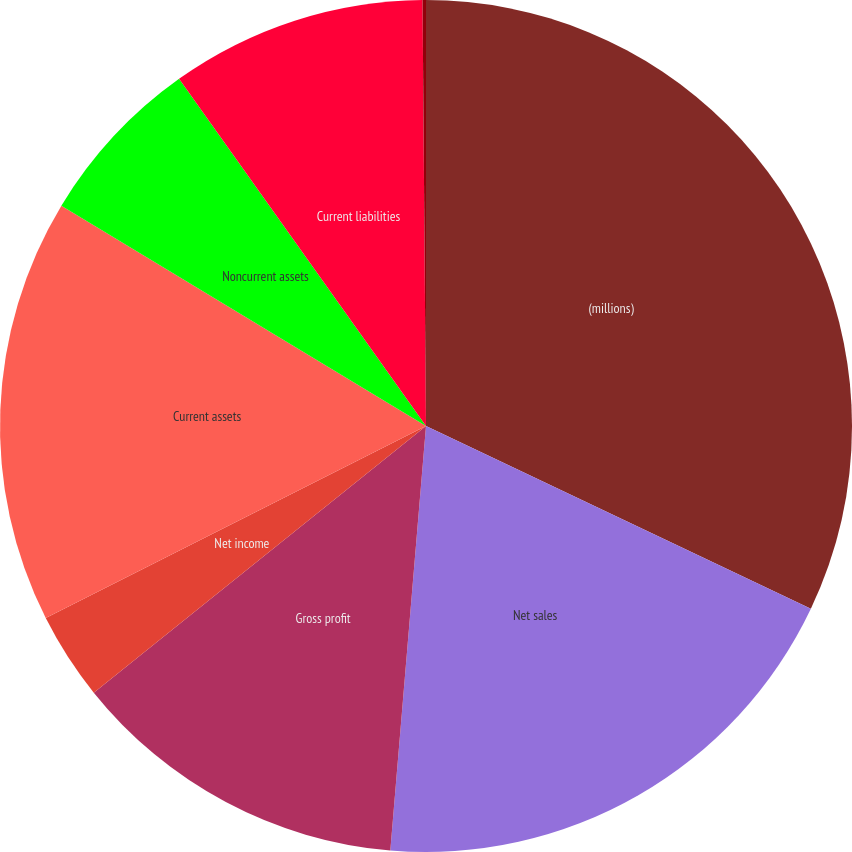<chart> <loc_0><loc_0><loc_500><loc_500><pie_chart><fcel>(millions)<fcel>Net sales<fcel>Gross profit<fcel>Net income<fcel>Current assets<fcel>Noncurrent assets<fcel>Current liabilities<fcel>Noncurrent liabilities<nl><fcel>32.05%<fcel>19.28%<fcel>12.9%<fcel>3.32%<fcel>16.09%<fcel>6.51%<fcel>9.71%<fcel>0.13%<nl></chart> 